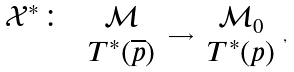<formula> <loc_0><loc_0><loc_500><loc_500>\begin{array} { c } \mathcal { X } ^ { * } \colon \\ \\ \end{array} \, \begin{array} { c } \mathcal { M } \\ T ^ { * } ( \overline { p } ) \end{array} \longrightarrow \begin{array} { c } \mathcal { M } _ { 0 } \\ T ^ { * } ( p ) \end{array} ,</formula> 